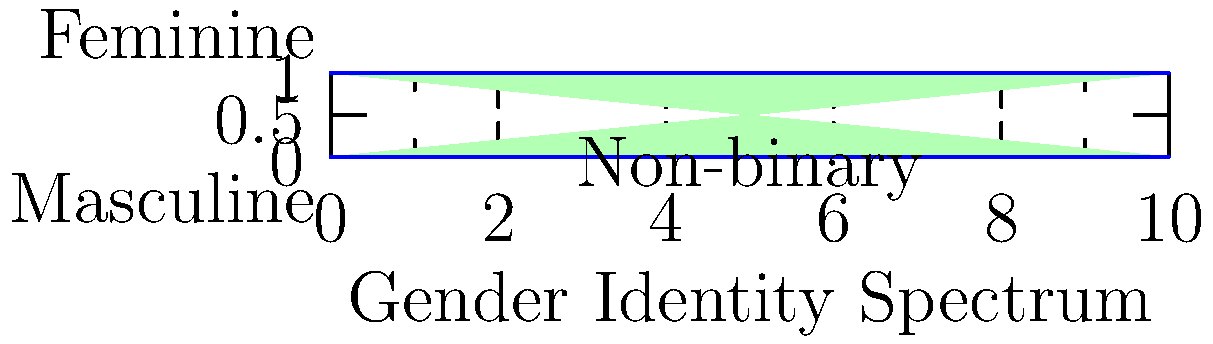In the gender identity spectrum shown above, which area represents individuals who may identify with aspects of both masculine and feminine identities, challenging the binary concept of gender? To answer this question, we need to analyze the gender identity spectrum presented in the image:

1. The x-axis represents the gender identity spectrum, ranging from masculine to feminine.
2. The y-axis represents the intensity or degree of identification with these gender identities.
3. The bottom of the graph (y=0) is labeled "Masculine," representing traditionally male-associated identities.
4. The top of the graph (y=1) is labeled "Feminine," representing traditionally female-associated identities.
5. The middle area of the graph is labeled "Non-binary," which represents identities that don't fit strictly into the masculine or feminine categories.
6. The gradient from pink to green in the background represents the fluidity and diversity of gender identities.

The area that represents individuals who may identify with aspects of both masculine and feminine identities, thus challenging the binary concept of gender, is the middle section labeled "Non-binary." This area encompasses identities that don't conform to strict masculine or feminine categories and allows for a more fluid and diverse understanding of gender.
Answer: Non-binary 